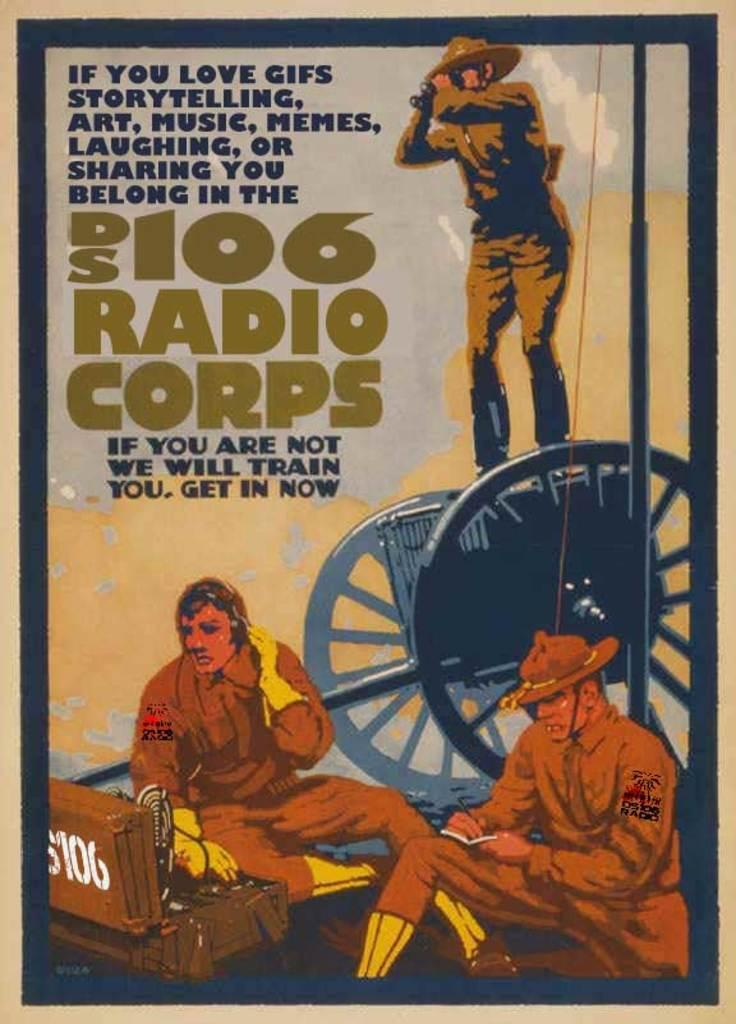What is featured on the poster in the image? The poster contains depictions of persons and text. Where is the cart located in the image? The cart is on the right side of the image. What is present in the bottom left of the image? There is a box in the bottom left of the image. What type of writer is depicted on the poster? There is no writer depicted on the poster; it contains depictions of persons, but their occupations are not specified. 